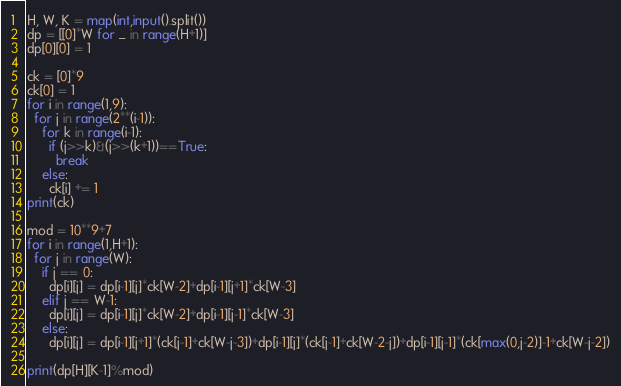Convert code to text. <code><loc_0><loc_0><loc_500><loc_500><_Python_>H, W, K = map(int,input().split())
dp = [[0]*W for _ in range(H+1)]
dp[0][0] = 1

ck = [0]*9
ck[0] = 1
for i in range(1,9):
  for j in range(2**(i-1)):
    for k in range(i-1):
      if (j>>k)&(j>>(k+1))==True:
        break
    else:
      ck[i] += 1
print(ck)

mod = 10**9+7
for i in range(1,H+1):
  for j in range(W):
    if j == 0:
      dp[i][j] = dp[i-1][j]*ck[W-2]+dp[i-1][j+1]*ck[W-3]
    elif j == W-1:
      dp[i][j] = dp[i-1][j]*ck[W-2]+dp[i-1][j-1]*ck[W-3] 
    else:
      dp[i][j] = dp[i-1][j+1]*(ck[j-1]+ck[W-j-3])+dp[i-1][j]*(ck[j-1]+ck[W-2-j])+dp[i-1][j-1]*(ck[max(0,j-2)]-1+ck[W-j-2])

print(dp[H][K-1]%mod)</code> 